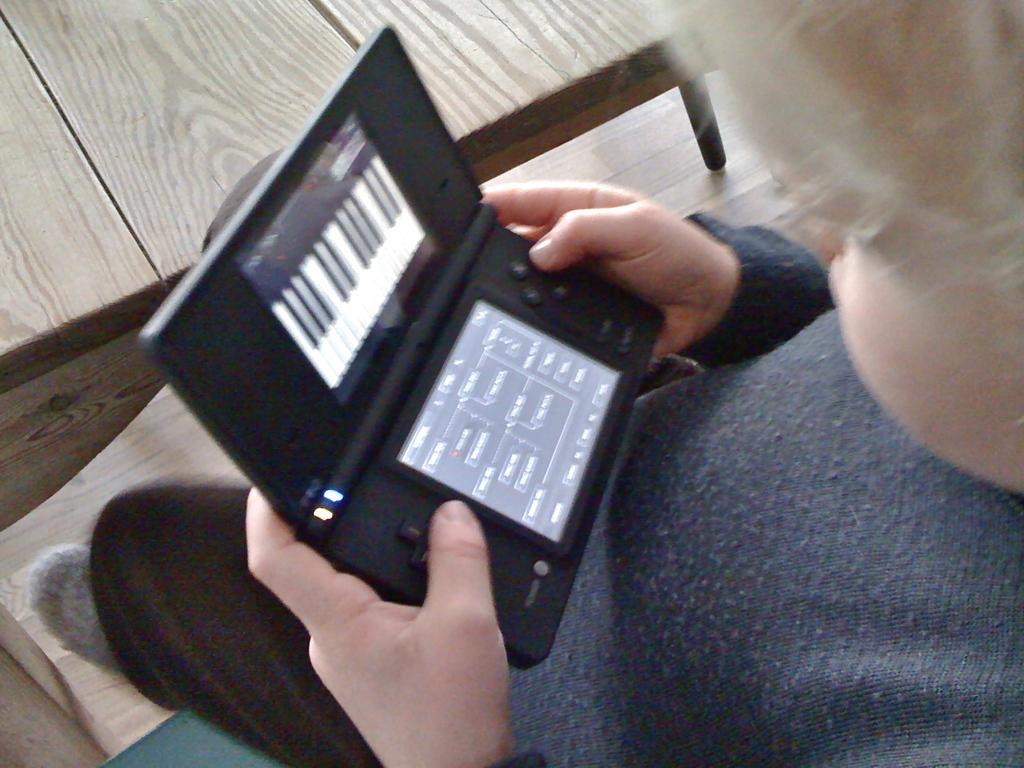What is the main subject on the right side of the image? There is a boy on the right side of the image. What is the boy doing in the image? The boy is playing in the image. What is the boy holding in the image? The boy is holding an object in the image. What can be seen in the background of the image? There is a floor visible in the background of the image. What type of furniture is present at the top of the image? There is a table at the top of the image. What type of flesh can be seen on the boy's face in the image? There is no flesh visible on the boy's face in the image; it is a photograph or drawing, not a real person. Is the boy a spy in the image? There is no indication in the image that the boy is a spy. 